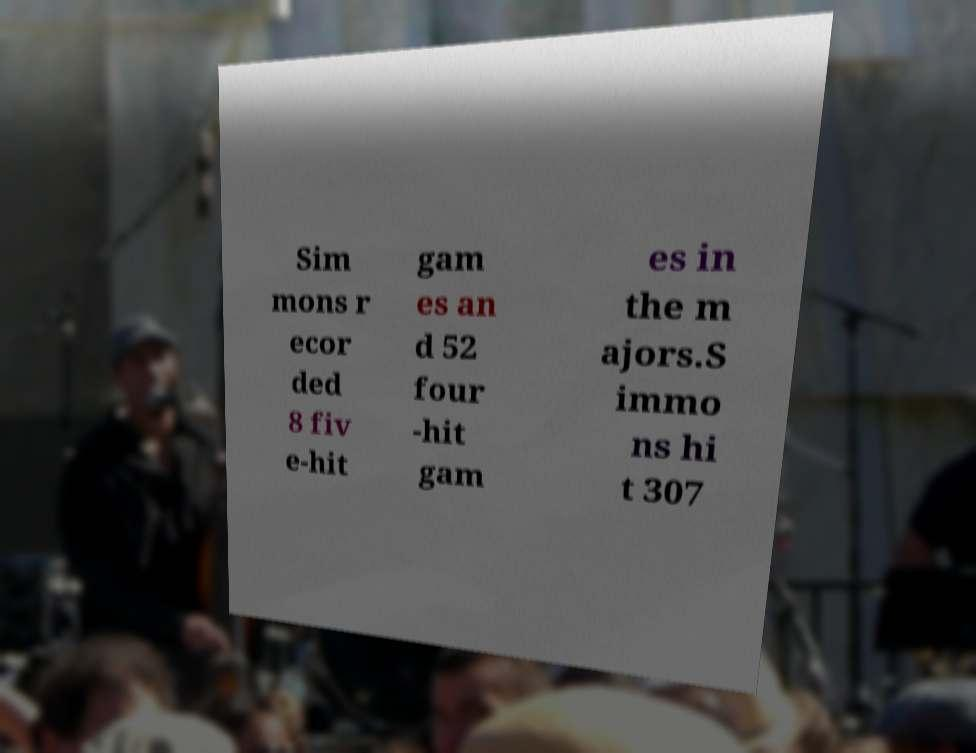I need the written content from this picture converted into text. Can you do that? Sim mons r ecor ded 8 fiv e-hit gam es an d 52 four -hit gam es in the m ajors.S immo ns hi t 307 